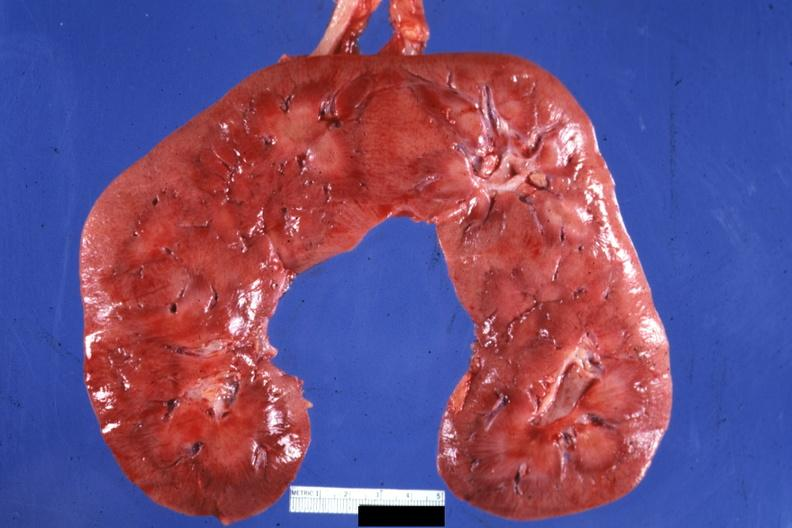s siamese twins present?
Answer the question using a single word or phrase. No 